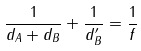Convert formula to latex. <formula><loc_0><loc_0><loc_500><loc_500>\frac { 1 } { d _ { A } + d _ { B } } + \frac { 1 } { d _ { B } ^ { \prime } } = \frac { 1 } { f }</formula> 